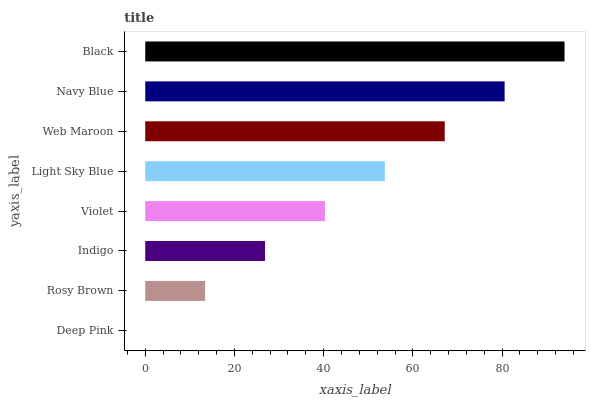Is Deep Pink the minimum?
Answer yes or no. Yes. Is Black the maximum?
Answer yes or no. Yes. Is Rosy Brown the minimum?
Answer yes or no. No. Is Rosy Brown the maximum?
Answer yes or no. No. Is Rosy Brown greater than Deep Pink?
Answer yes or no. Yes. Is Deep Pink less than Rosy Brown?
Answer yes or no. Yes. Is Deep Pink greater than Rosy Brown?
Answer yes or no. No. Is Rosy Brown less than Deep Pink?
Answer yes or no. No. Is Light Sky Blue the high median?
Answer yes or no. Yes. Is Violet the low median?
Answer yes or no. Yes. Is Rosy Brown the high median?
Answer yes or no. No. Is Black the low median?
Answer yes or no. No. 